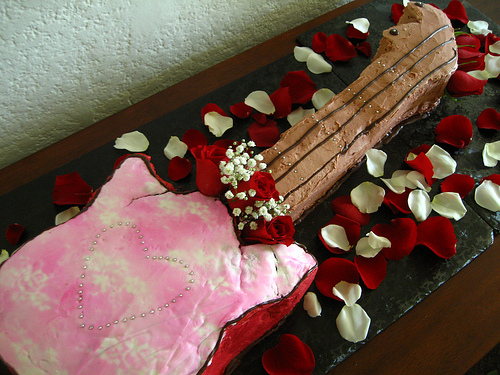<image>
Is the chocolate next to the studs? No. The chocolate is not positioned next to the studs. They are located in different areas of the scene. 